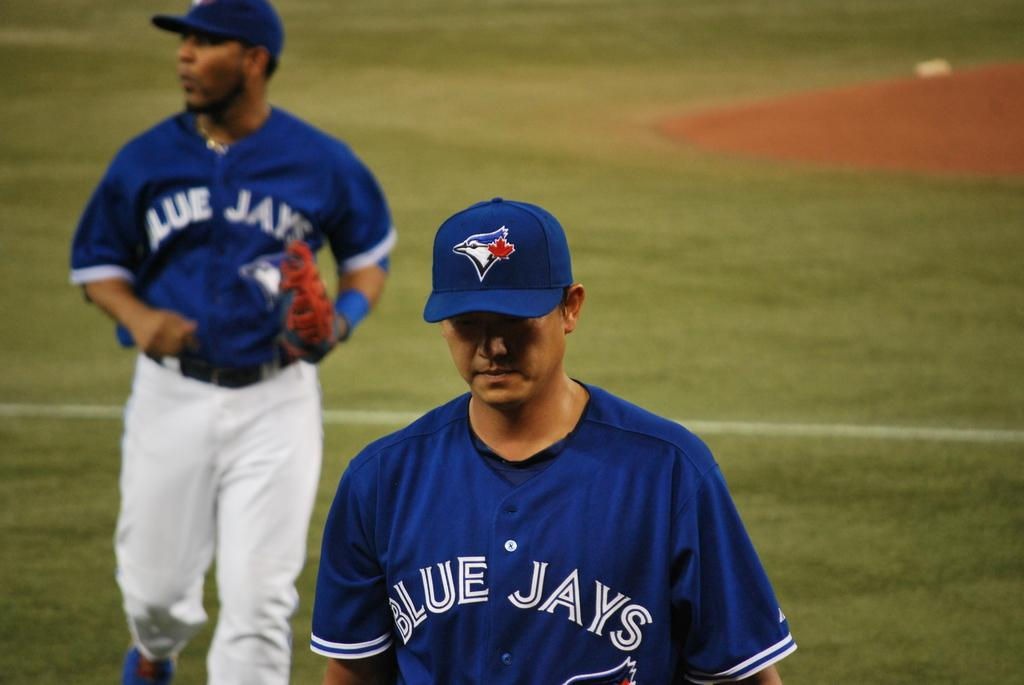<image>
Write a terse but informative summary of the picture. a person wearing a Blue Jays jersey on a field 